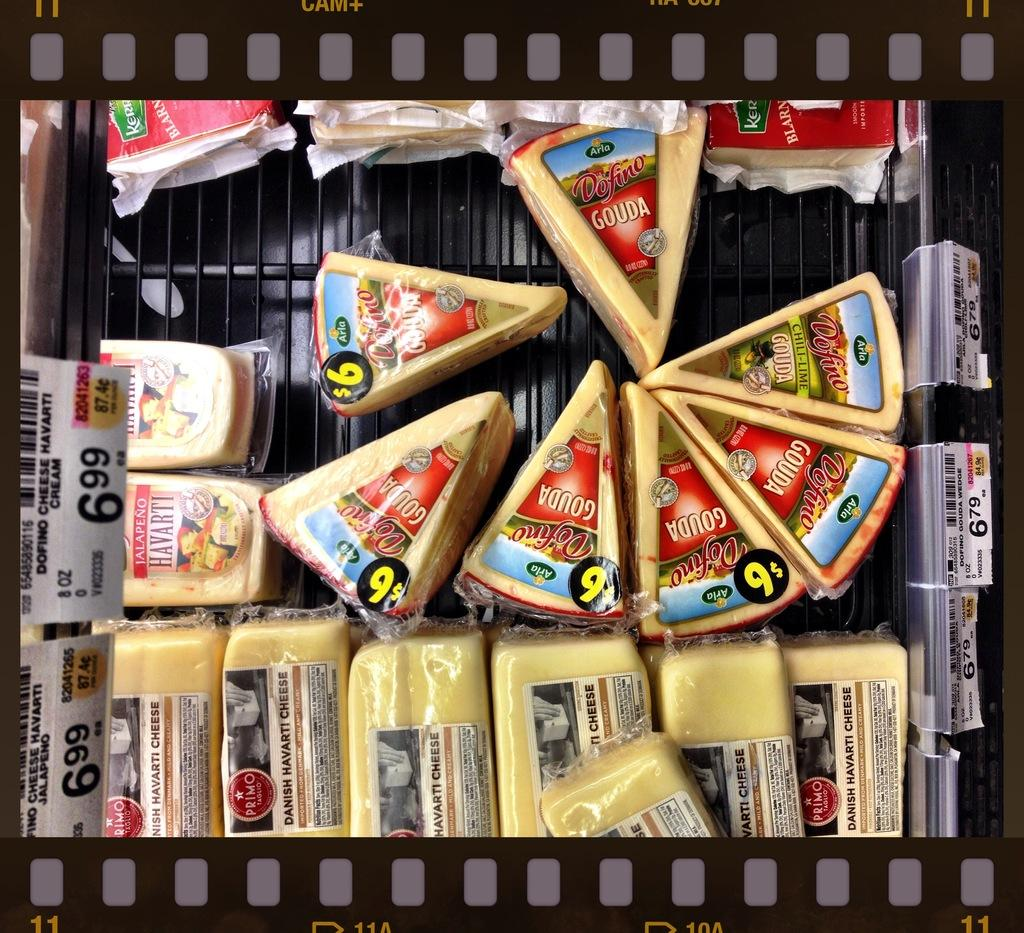<image>
Share a concise interpretation of the image provided. the number 6 is on the cover of the cheese 